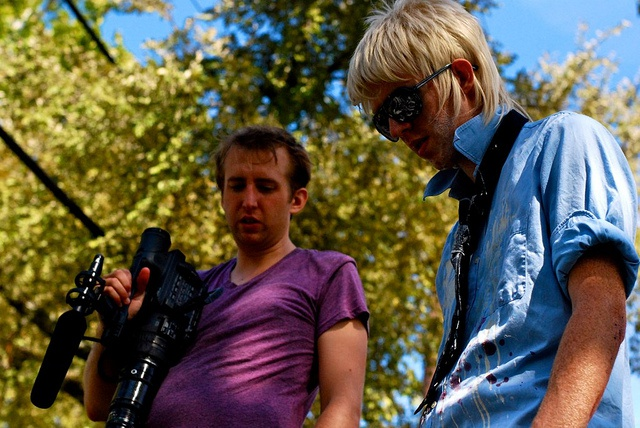Describe the objects in this image and their specific colors. I can see people in olive, black, blue, maroon, and navy tones, people in olive, black, purple, maroon, and brown tones, and tie in olive, black, blue, gray, and navy tones in this image. 